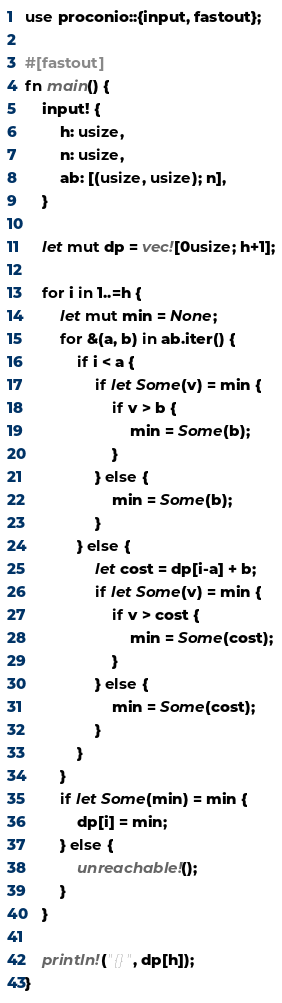Convert code to text. <code><loc_0><loc_0><loc_500><loc_500><_Rust_>use proconio::{input, fastout};

#[fastout]
fn main() {
    input! {
        h: usize,
        n: usize,
        ab: [(usize, usize); n],
    }

    let mut dp = vec![0usize; h+1];
    
    for i in 1..=h {
        let mut min = None;
        for &(a, b) in ab.iter() {
            if i < a {
                if let Some(v) = min {
                    if v > b {
                        min = Some(b);
                    }
                } else {
                    min = Some(b);
                }
            } else {
                let cost = dp[i-a] + b;
                if let Some(v) = min {
                    if v > cost {
                        min = Some(cost);
                    }
                } else {
                    min = Some(cost);
                }
            }
        }
        if let Some(min) = min {
            dp[i] = min;
        } else {
            unreachable!();
        }
    }

    println!("{}", dp[h]);
}</code> 